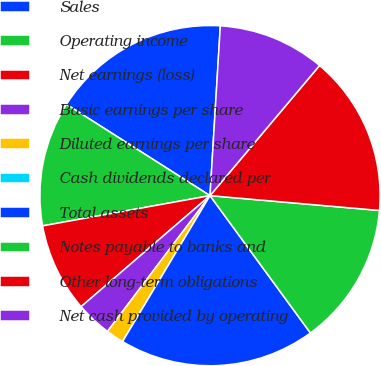<chart> <loc_0><loc_0><loc_500><loc_500><pie_chart><fcel>Sales<fcel>Operating income<fcel>Net earnings (loss)<fcel>Basic earnings per share<fcel>Diluted earnings per share<fcel>Cash dividends declared per<fcel>Total assets<fcel>Notes payable to banks and<fcel>Other long-term obligations<fcel>Net cash provided by operating<nl><fcel>16.95%<fcel>11.86%<fcel>8.47%<fcel>3.39%<fcel>1.7%<fcel>0.0%<fcel>18.64%<fcel>13.56%<fcel>15.25%<fcel>10.17%<nl></chart> 